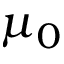<formula> <loc_0><loc_0><loc_500><loc_500>\mu _ { 0 }</formula> 